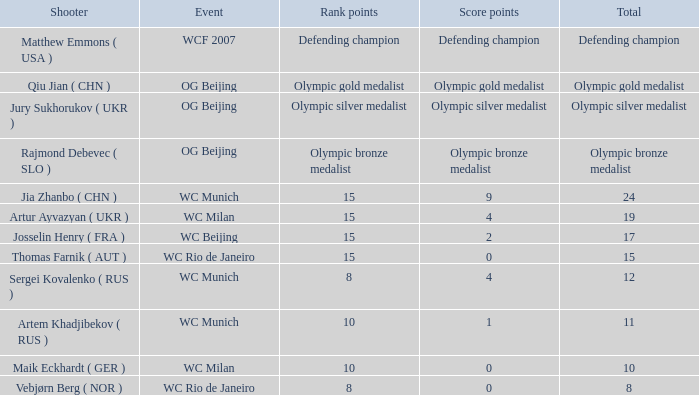With an overall 11, and 10 position points, what are the scoring points? 1.0. 